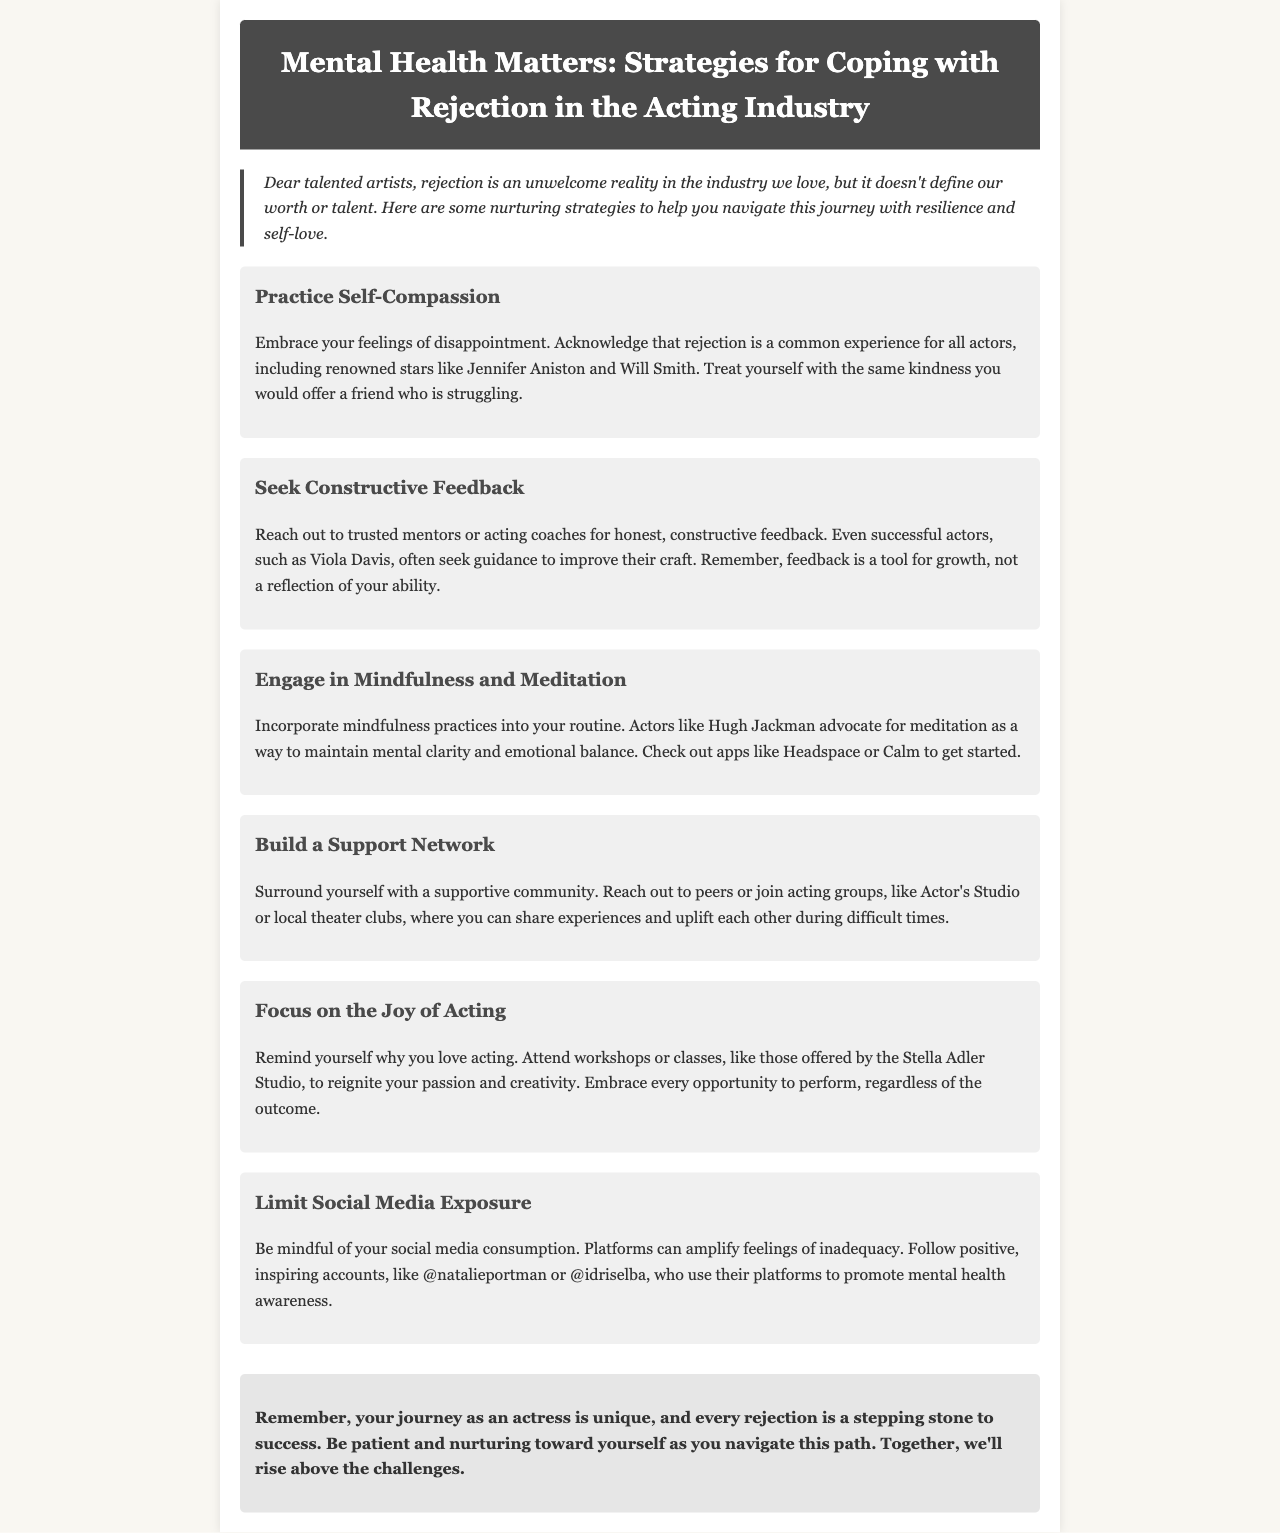what is the title of the newsletter? The title is the main heading of the document, providing the topic.
Answer: Mental Health Matters: Strategies for Coping with Rejection in the Acting Industry who are two actors mentioned in the document? The document lists examples of actors who experience rejection, serving as relatable figures.
Answer: Jennifer Aniston, Will Smith what is one strategy for coping with rejection? This question seeks a specific strategy highlighted in the document.
Answer: Practice Self-Compassion which activity is recommended for maintaining emotional balance? The document suggests a specific activity for emotional well-being.
Answer: Mindfulness and Meditation what is the purpose of seeking constructive feedback? This question targets the reasoning behind obtaining feedback from mentors.
Answer: A tool for growth how should you manage social media exposure? The document outlines advice regarding social media consumption related to mental health.
Answer: Limit social media exposure what type of community should you build? This question focuses on the recommendation for support systems in the acting industry.
Answer: Supportive community what do you call the supportive groups mentioned in the document? This question looks for the names of specific groups that provide support to actors.
Answer: Actor's Studio or local theater clubs 